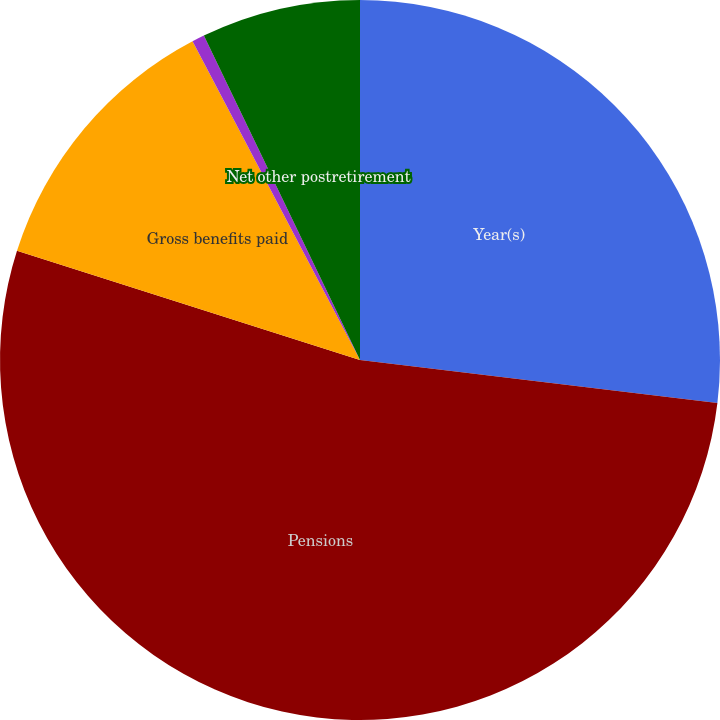Convert chart to OTSL. <chart><loc_0><loc_0><loc_500><loc_500><pie_chart><fcel>Year(s)<fcel>Pensions<fcel>Gross benefits paid<fcel>Subsidies<fcel>Net other postretirement<nl><fcel>26.91%<fcel>53.0%<fcel>12.39%<fcel>0.56%<fcel>7.14%<nl></chart> 